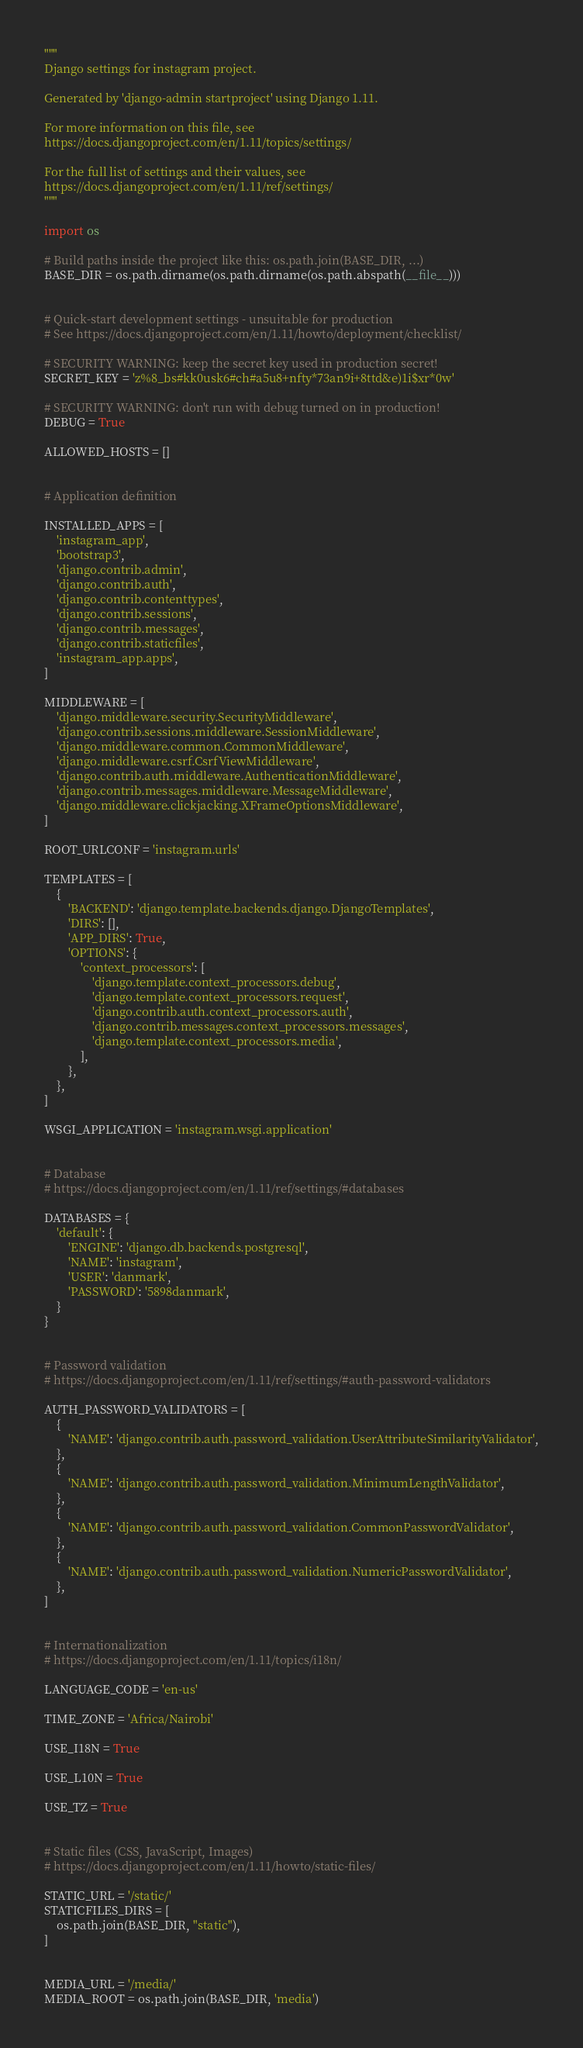<code> <loc_0><loc_0><loc_500><loc_500><_Python_>"""
Django settings for instagram project.

Generated by 'django-admin startproject' using Django 1.11.

For more information on this file, see
https://docs.djangoproject.com/en/1.11/topics/settings/

For the full list of settings and their values, see
https://docs.djangoproject.com/en/1.11/ref/settings/
"""

import os

# Build paths inside the project like this: os.path.join(BASE_DIR, ...)
BASE_DIR = os.path.dirname(os.path.dirname(os.path.abspath(__file__)))


# Quick-start development settings - unsuitable for production
# See https://docs.djangoproject.com/en/1.11/howto/deployment/checklist/

# SECURITY WARNING: keep the secret key used in production secret!
SECRET_KEY = 'z%8_bs#kk0usk6#ch#a5u8+nfty*73an9i+8ttd&e)1i$xr*0w'

# SECURITY WARNING: don't run with debug turned on in production!
DEBUG = True

ALLOWED_HOSTS = []


# Application definition

INSTALLED_APPS = [
    'instagram_app',
    'bootstrap3',
    'django.contrib.admin',
    'django.contrib.auth',
    'django.contrib.contenttypes',
    'django.contrib.sessions',
    'django.contrib.messages',
    'django.contrib.staticfiles',
    'instagram_app.apps',
]

MIDDLEWARE = [
    'django.middleware.security.SecurityMiddleware',
    'django.contrib.sessions.middleware.SessionMiddleware',
    'django.middleware.common.CommonMiddleware',
    'django.middleware.csrf.CsrfViewMiddleware',
    'django.contrib.auth.middleware.AuthenticationMiddleware',
    'django.contrib.messages.middleware.MessageMiddleware',
    'django.middleware.clickjacking.XFrameOptionsMiddleware',
]

ROOT_URLCONF = 'instagram.urls'

TEMPLATES = [
    {
        'BACKEND': 'django.template.backends.django.DjangoTemplates',
        'DIRS': [],
        'APP_DIRS': True,
        'OPTIONS': {
            'context_processors': [
                'django.template.context_processors.debug',
                'django.template.context_processors.request',
                'django.contrib.auth.context_processors.auth',
                'django.contrib.messages.context_processors.messages',
                'django.template.context_processors.media',
            ],
        },
    },
]

WSGI_APPLICATION = 'instagram.wsgi.application'


# Database
# https://docs.djangoproject.com/en/1.11/ref/settings/#databases

DATABASES = {
    'default': {
        'ENGINE': 'django.db.backends.postgresql',
        'NAME': 'instagram',
        'USER': 'danmark',
        'PASSWORD': '5898danmark',
    }
}


# Password validation
# https://docs.djangoproject.com/en/1.11/ref/settings/#auth-password-validators

AUTH_PASSWORD_VALIDATORS = [
    {
        'NAME': 'django.contrib.auth.password_validation.UserAttributeSimilarityValidator',
    },
    {
        'NAME': 'django.contrib.auth.password_validation.MinimumLengthValidator',
    },
    {
        'NAME': 'django.contrib.auth.password_validation.CommonPasswordValidator',
    },
    {
        'NAME': 'django.contrib.auth.password_validation.NumericPasswordValidator',
    },
]


# Internationalization
# https://docs.djangoproject.com/en/1.11/topics/i18n/

LANGUAGE_CODE = 'en-us'

TIME_ZONE = 'Africa/Nairobi'

USE_I18N = True

USE_L10N = True

USE_TZ = True


# Static files (CSS, JavaScript, Images)
# https://docs.djangoproject.com/en/1.11/howto/static-files/

STATIC_URL = '/static/'
STATICFILES_DIRS = [
    os.path.join(BASE_DIR, "static"),
]


MEDIA_URL = '/media/'
MEDIA_ROOT = os.path.join(BASE_DIR, 'media')
</code> 